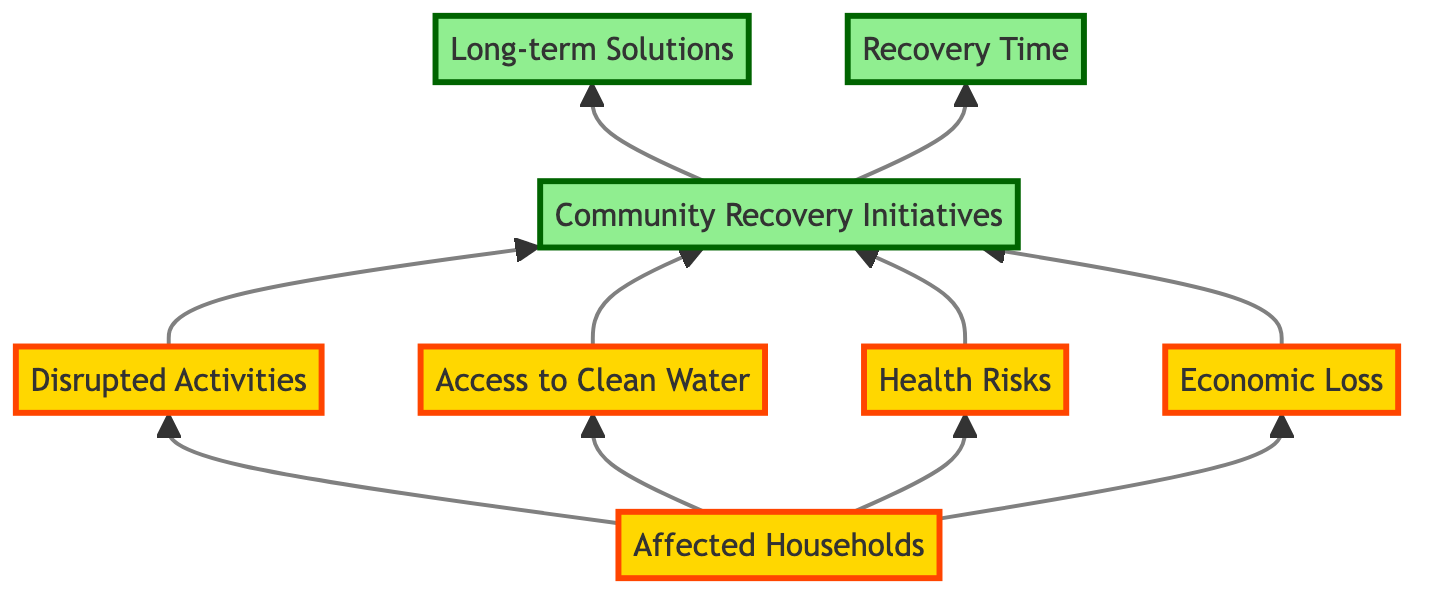What is the main focus of the diagram? The main focus of the diagram is to assess the impact of electricity blackouts on the community. This includes the affected households, disrupted activities, health risks, economic loss, and recovery measures.
Answer: Community impact assessment How many nodes are there in the diagram? Counting the elements visually, there are eight nodes represented in the diagram. Each node corresponds to a specific aspect of the community impact due to electricity blackouts.
Answer: Eight Which element leads to "Community Recovery Initiatives"? The elements that lead to "Community Recovery Initiatives" include "Disrupted Activities," "Access to Clean Water," "Health Risks," and "Economic Loss." These elements are interconnected and highlight the challenges faced that prompt community recovery initiatives.
Answer: Disrupted Activities, Access to Clean Water, Health Risks, Economic Loss What type of relationship exists between "Affected Households" and "Health Risks"? The relationship is that "Affected Households" directly influences "Health Risks." This can be inferred from the flow direction in the diagram, indicating that the number of impacted households affects the health risks faced by the community.
Answer: Direct influence What do "Long-term Solutions" rely on in the diagram? "Long-term Solutions" rely on "Community Recovery Initiatives," as indicated by the flow relationship showing that community efforts to recover lead to planning and implementation of long-term strategies for electricity reliability.
Answer: Community Recovery Initiatives How does "Economic Loss" connect to the recovery process? "Economic Loss" connects to the recovery process by influencing "Community Recovery Initiatives." Economic impact from blackouts leads to community programs aimed at addressing these losses and facilitating recovery.
Answer: Through Community Recovery Initiatives What is the significance of "Recovery Time" in this context? "Recovery Time" represents the average time taken for households and the community to recover from blackouts. It signifies the effectiveness of the recovery initiatives and long-term solutions in mitigating the impact of the blackout.
Answer: Effectiveness of recovery efforts What are the two categories of elements in the diagram? The two categories of elements are "impact" and "recovery." Impact elements represent the effects of blackouts, while recovery elements reflect community actions taken to address those effects.
Answer: Impact and recovery 